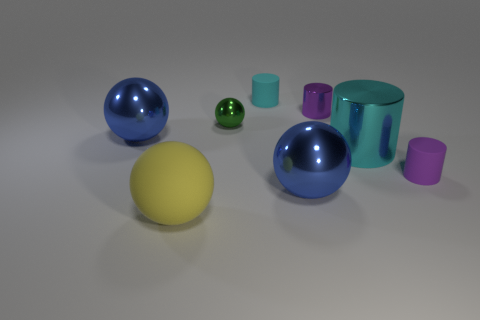Add 2 tiny green metallic blocks. How many objects exist? 10 Add 5 tiny cyan matte cylinders. How many tiny cyan matte cylinders exist? 6 Subtract 0 purple balls. How many objects are left? 8 Subtract all cyan cylinders. Subtract all cyan rubber things. How many objects are left? 5 Add 8 tiny green balls. How many tiny green balls are left? 9 